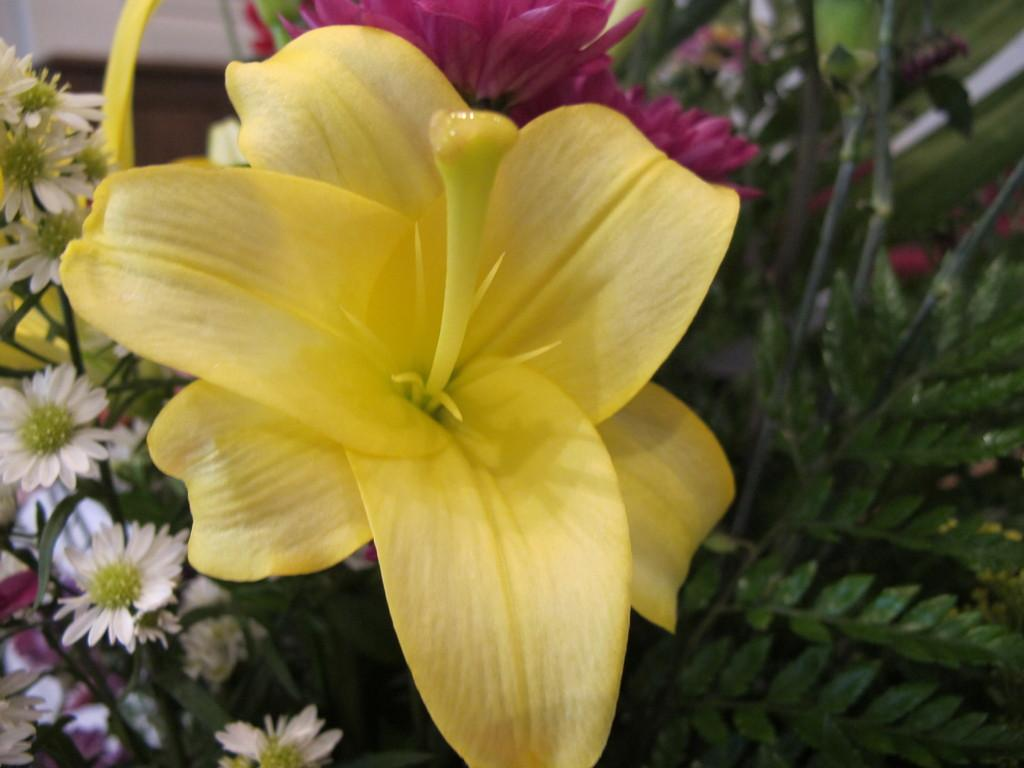What type of plant is in the image? The plant in the image has flowers on it. What colors are the flowers on the plant? The flowers are in white, yellow, and pink colors. What can be seen behind the plant in the image? There is a wall visible at the back of the image. How many babies are playing the guitar in the image? There are no babies or guitars present in the image. What type of ship can be seen sailing in the background of the image? There is no ship visible in the image; it only features a plant with flowers and a wall in the background. 